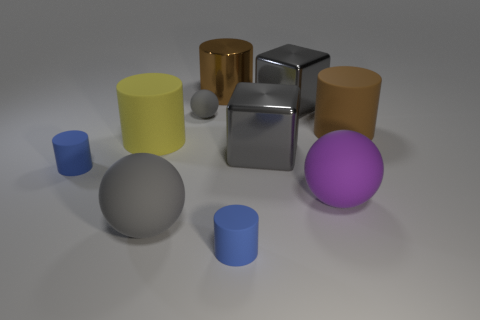Subtract 1 cylinders. How many cylinders are left? 4 Subtract all blue cylinders. How many cylinders are left? 3 Subtract all blue cylinders. How many cylinders are left? 3 Subtract all red cylinders. Subtract all purple blocks. How many cylinders are left? 5 Subtract all balls. How many objects are left? 7 Subtract all gray metallic objects. Subtract all tiny things. How many objects are left? 5 Add 6 large gray matte spheres. How many large gray matte spheres are left? 7 Add 5 tiny gray metallic cylinders. How many tiny gray metallic cylinders exist? 5 Subtract 1 purple balls. How many objects are left? 9 